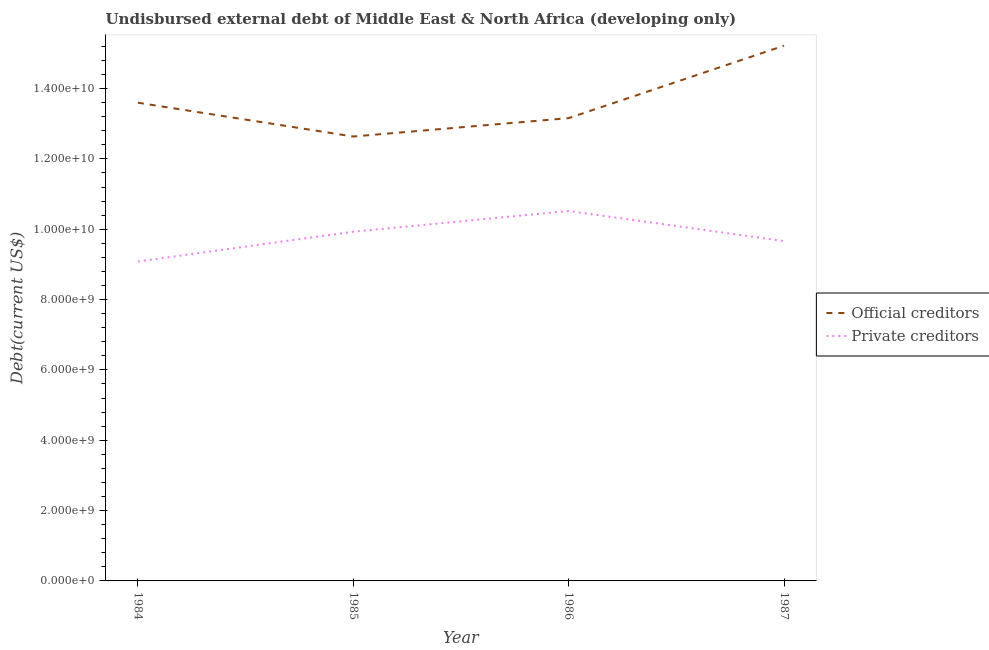How many different coloured lines are there?
Offer a very short reply. 2. Does the line corresponding to undisbursed external debt of official creditors intersect with the line corresponding to undisbursed external debt of private creditors?
Ensure brevity in your answer.  No. What is the undisbursed external debt of official creditors in 1987?
Make the answer very short. 1.52e+1. Across all years, what is the maximum undisbursed external debt of official creditors?
Offer a terse response. 1.52e+1. Across all years, what is the minimum undisbursed external debt of official creditors?
Make the answer very short. 1.26e+1. What is the total undisbursed external debt of official creditors in the graph?
Make the answer very short. 5.46e+1. What is the difference between the undisbursed external debt of official creditors in 1984 and that in 1987?
Your answer should be very brief. -1.62e+09. What is the difference between the undisbursed external debt of private creditors in 1987 and the undisbursed external debt of official creditors in 1985?
Your answer should be very brief. -2.97e+09. What is the average undisbursed external debt of official creditors per year?
Ensure brevity in your answer.  1.37e+1. In the year 1985, what is the difference between the undisbursed external debt of official creditors and undisbursed external debt of private creditors?
Your answer should be very brief. 2.71e+09. In how many years, is the undisbursed external debt of private creditors greater than 2800000000 US$?
Offer a very short reply. 4. What is the ratio of the undisbursed external debt of private creditors in 1986 to that in 1987?
Your answer should be very brief. 1.09. Is the difference between the undisbursed external debt of private creditors in 1985 and 1987 greater than the difference between the undisbursed external debt of official creditors in 1985 and 1987?
Provide a succinct answer. Yes. What is the difference between the highest and the second highest undisbursed external debt of official creditors?
Your answer should be compact. 1.62e+09. What is the difference between the highest and the lowest undisbursed external debt of official creditors?
Your response must be concise. 2.58e+09. In how many years, is the undisbursed external debt of private creditors greater than the average undisbursed external debt of private creditors taken over all years?
Make the answer very short. 2. Is the sum of the undisbursed external debt of official creditors in 1986 and 1987 greater than the maximum undisbursed external debt of private creditors across all years?
Ensure brevity in your answer.  Yes. How many years are there in the graph?
Give a very brief answer. 4. What is the difference between two consecutive major ticks on the Y-axis?
Your response must be concise. 2.00e+09. Does the graph contain any zero values?
Keep it short and to the point. No. Does the graph contain grids?
Your response must be concise. No. How are the legend labels stacked?
Your response must be concise. Vertical. What is the title of the graph?
Give a very brief answer. Undisbursed external debt of Middle East & North Africa (developing only). What is the label or title of the X-axis?
Keep it short and to the point. Year. What is the label or title of the Y-axis?
Provide a short and direct response. Debt(current US$). What is the Debt(current US$) of Official creditors in 1984?
Make the answer very short. 1.36e+1. What is the Debt(current US$) in Private creditors in 1984?
Offer a terse response. 9.08e+09. What is the Debt(current US$) in Official creditors in 1985?
Offer a terse response. 1.26e+1. What is the Debt(current US$) of Private creditors in 1985?
Make the answer very short. 9.93e+09. What is the Debt(current US$) in Official creditors in 1986?
Your response must be concise. 1.32e+1. What is the Debt(current US$) in Private creditors in 1986?
Provide a succinct answer. 1.05e+1. What is the Debt(current US$) of Official creditors in 1987?
Your answer should be compact. 1.52e+1. What is the Debt(current US$) of Private creditors in 1987?
Give a very brief answer. 9.66e+09. Across all years, what is the maximum Debt(current US$) of Official creditors?
Offer a terse response. 1.52e+1. Across all years, what is the maximum Debt(current US$) in Private creditors?
Provide a succinct answer. 1.05e+1. Across all years, what is the minimum Debt(current US$) in Official creditors?
Give a very brief answer. 1.26e+1. Across all years, what is the minimum Debt(current US$) of Private creditors?
Make the answer very short. 9.08e+09. What is the total Debt(current US$) of Official creditors in the graph?
Your answer should be compact. 5.46e+1. What is the total Debt(current US$) of Private creditors in the graph?
Offer a very short reply. 3.92e+1. What is the difference between the Debt(current US$) of Official creditors in 1984 and that in 1985?
Your answer should be compact. 9.62e+08. What is the difference between the Debt(current US$) of Private creditors in 1984 and that in 1985?
Ensure brevity in your answer.  -8.47e+08. What is the difference between the Debt(current US$) in Official creditors in 1984 and that in 1986?
Ensure brevity in your answer.  4.39e+08. What is the difference between the Debt(current US$) of Private creditors in 1984 and that in 1986?
Ensure brevity in your answer.  -1.44e+09. What is the difference between the Debt(current US$) of Official creditors in 1984 and that in 1987?
Give a very brief answer. -1.62e+09. What is the difference between the Debt(current US$) of Private creditors in 1984 and that in 1987?
Your response must be concise. -5.79e+08. What is the difference between the Debt(current US$) of Official creditors in 1985 and that in 1986?
Provide a short and direct response. -5.23e+08. What is the difference between the Debt(current US$) of Private creditors in 1985 and that in 1986?
Your answer should be very brief. -5.90e+08. What is the difference between the Debt(current US$) in Official creditors in 1985 and that in 1987?
Provide a succinct answer. -2.58e+09. What is the difference between the Debt(current US$) of Private creditors in 1985 and that in 1987?
Ensure brevity in your answer.  2.67e+08. What is the difference between the Debt(current US$) in Official creditors in 1986 and that in 1987?
Make the answer very short. -2.06e+09. What is the difference between the Debt(current US$) of Private creditors in 1986 and that in 1987?
Offer a very short reply. 8.58e+08. What is the difference between the Debt(current US$) of Official creditors in 1984 and the Debt(current US$) of Private creditors in 1985?
Keep it short and to the point. 3.67e+09. What is the difference between the Debt(current US$) in Official creditors in 1984 and the Debt(current US$) in Private creditors in 1986?
Provide a succinct answer. 3.08e+09. What is the difference between the Debt(current US$) in Official creditors in 1984 and the Debt(current US$) in Private creditors in 1987?
Your answer should be compact. 3.94e+09. What is the difference between the Debt(current US$) in Official creditors in 1985 and the Debt(current US$) in Private creditors in 1986?
Ensure brevity in your answer.  2.12e+09. What is the difference between the Debt(current US$) in Official creditors in 1985 and the Debt(current US$) in Private creditors in 1987?
Your answer should be compact. 2.97e+09. What is the difference between the Debt(current US$) in Official creditors in 1986 and the Debt(current US$) in Private creditors in 1987?
Make the answer very short. 3.50e+09. What is the average Debt(current US$) in Official creditors per year?
Your response must be concise. 1.37e+1. What is the average Debt(current US$) of Private creditors per year?
Your answer should be compact. 9.80e+09. In the year 1984, what is the difference between the Debt(current US$) in Official creditors and Debt(current US$) in Private creditors?
Offer a terse response. 4.52e+09. In the year 1985, what is the difference between the Debt(current US$) in Official creditors and Debt(current US$) in Private creditors?
Offer a very short reply. 2.71e+09. In the year 1986, what is the difference between the Debt(current US$) in Official creditors and Debt(current US$) in Private creditors?
Provide a succinct answer. 2.64e+09. In the year 1987, what is the difference between the Debt(current US$) in Official creditors and Debt(current US$) in Private creditors?
Provide a succinct answer. 5.56e+09. What is the ratio of the Debt(current US$) of Official creditors in 1984 to that in 1985?
Provide a succinct answer. 1.08. What is the ratio of the Debt(current US$) in Private creditors in 1984 to that in 1985?
Keep it short and to the point. 0.91. What is the ratio of the Debt(current US$) of Private creditors in 1984 to that in 1986?
Your response must be concise. 0.86. What is the ratio of the Debt(current US$) in Official creditors in 1984 to that in 1987?
Your answer should be very brief. 0.89. What is the ratio of the Debt(current US$) in Private creditors in 1984 to that in 1987?
Your response must be concise. 0.94. What is the ratio of the Debt(current US$) of Official creditors in 1985 to that in 1986?
Offer a terse response. 0.96. What is the ratio of the Debt(current US$) in Private creditors in 1985 to that in 1986?
Offer a very short reply. 0.94. What is the ratio of the Debt(current US$) in Official creditors in 1985 to that in 1987?
Provide a succinct answer. 0.83. What is the ratio of the Debt(current US$) in Private creditors in 1985 to that in 1987?
Offer a very short reply. 1.03. What is the ratio of the Debt(current US$) of Official creditors in 1986 to that in 1987?
Your response must be concise. 0.86. What is the ratio of the Debt(current US$) in Private creditors in 1986 to that in 1987?
Keep it short and to the point. 1.09. What is the difference between the highest and the second highest Debt(current US$) in Official creditors?
Make the answer very short. 1.62e+09. What is the difference between the highest and the second highest Debt(current US$) of Private creditors?
Make the answer very short. 5.90e+08. What is the difference between the highest and the lowest Debt(current US$) in Official creditors?
Provide a succinct answer. 2.58e+09. What is the difference between the highest and the lowest Debt(current US$) in Private creditors?
Offer a very short reply. 1.44e+09. 